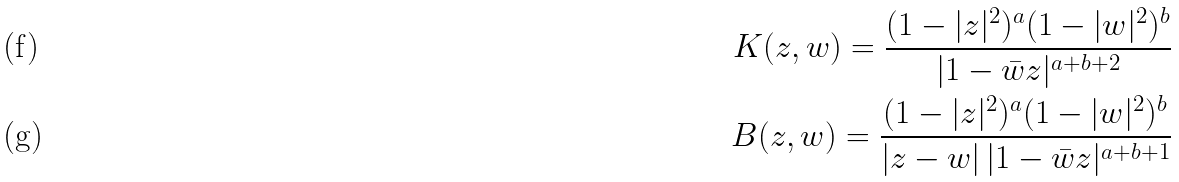<formula> <loc_0><loc_0><loc_500><loc_500>K ( z , w ) = \frac { ( 1 - | z | ^ { 2 } ) ^ { a } ( 1 - | w | ^ { 2 } ) ^ { b } } { | 1 - \bar { w } z | ^ { a + b + 2 } } \\ B ( z , w ) = \frac { ( 1 - | z | ^ { 2 } ) ^ { a } ( 1 - | w | ^ { 2 } ) ^ { b } } { | z - w | \, | 1 - \bar { w } z | ^ { a + b + 1 } }</formula> 